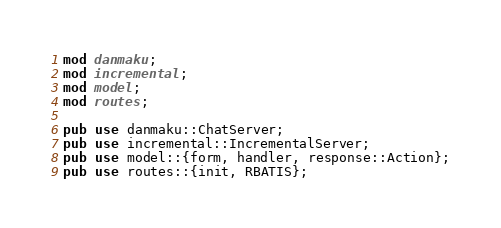Convert code to text. <code><loc_0><loc_0><loc_500><loc_500><_Rust_>mod danmaku;
mod incremental;
mod model;
mod routes;

pub use danmaku::ChatServer;
pub use incremental::IncrementalServer;
pub use model::{form, handler, response::Action};
pub use routes::{init, RBATIS};
</code> 